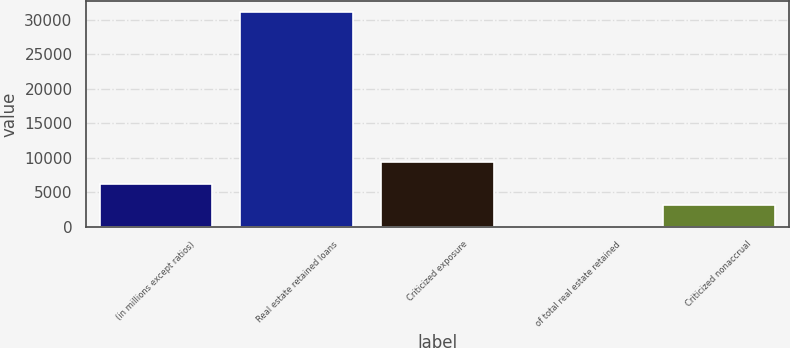Convert chart to OTSL. <chart><loc_0><loc_0><loc_500><loc_500><bar_chart><fcel>(in millions except ratios)<fcel>Real estate retained loans<fcel>Criticized exposure<fcel>of total real estate retained<fcel>Criticized nonaccrual<nl><fcel>6225.54<fcel>31077<fcel>9331.97<fcel>12.68<fcel>3119.11<nl></chart> 